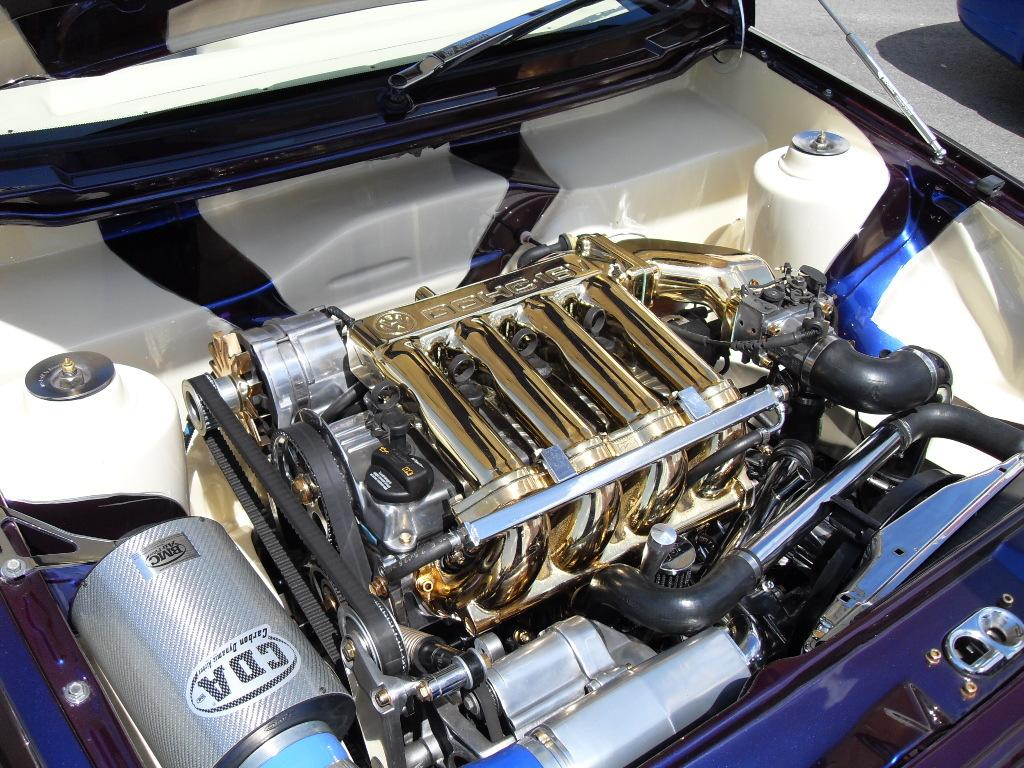What type of object is visible in the image? There are parts of a car visible in the image. What type of grass is growing on the car in the image? There is no grass growing on the car in the image; it only shows parts of a car. Can you describe the see any windows on the car in the image? The provided fact does not mention any windows on the car, so we cannot determine their presence from the image. 